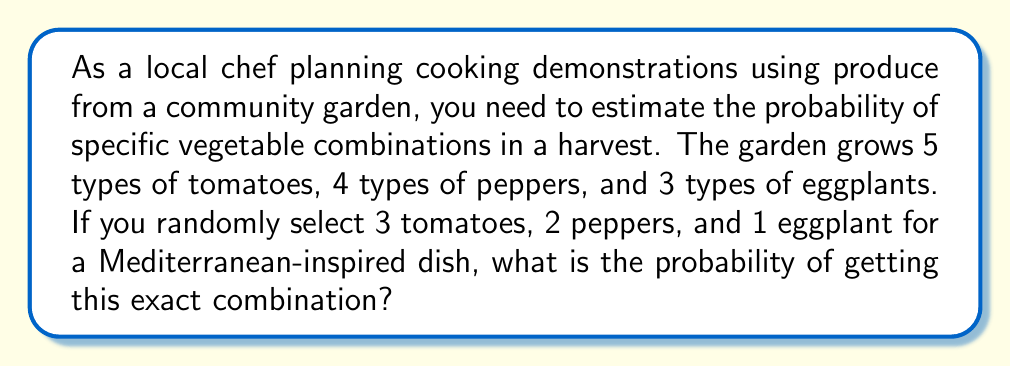Could you help me with this problem? To solve this problem, we'll use the multiplication principle of combinatorics. We need to calculate the number of ways to select each type of vegetable and then multiply these together to get the total number of possible combinations. Then, we'll divide 1 by this total to get the probability of selecting any specific combination.

1. Selecting 3 tomatoes from 5 types:
   We use the combination formula: $\binom{5}{3} = \frac{5!}{3!(5-3)!} = \frac{5!}{3!2!} = 10$

2. Selecting 2 peppers from 4 types:
   $\binom{4}{2} = \frac{4!}{2!(4-2)!} = \frac{4!}{2!2!} = 6$

3. Selecting 1 eggplant from 3 types:
   $\binom{3}{1} = \frac{3!}{1!(3-1)!} = \frac{3!}{1!2!} = 3$

4. Total number of possible combinations:
   $10 \times 6 \times 3 = 180$

5. Probability of getting any specific combination:
   $\frac{1}{180}$

Therefore, the probability of getting any specific combination of 3 tomatoes, 2 peppers, and 1 eggplant is $\frac{1}{180}$.
Answer: $\frac{1}{180}$ 